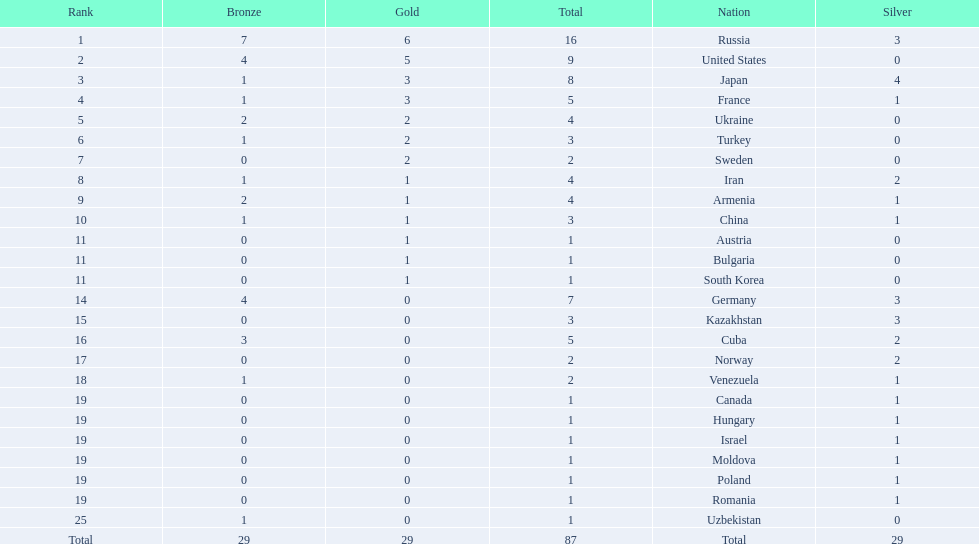Where did iran rank? 8. Where did germany rank? 14. Which of those did make it into the top 10 rank? Germany. 